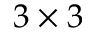Convert formula to latex. <formula><loc_0><loc_0><loc_500><loc_500>3 \times 3</formula> 